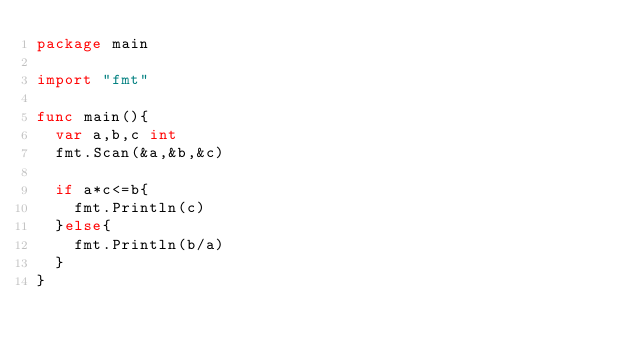<code> <loc_0><loc_0><loc_500><loc_500><_Go_>package main

import "fmt"

func main(){
  var a,b,c int
  fmt.Scan(&a,&b,&c)
  
  if a*c<=b{
    fmt.Println(c)
  }else{
    fmt.Println(b/a)
  }
}</code> 